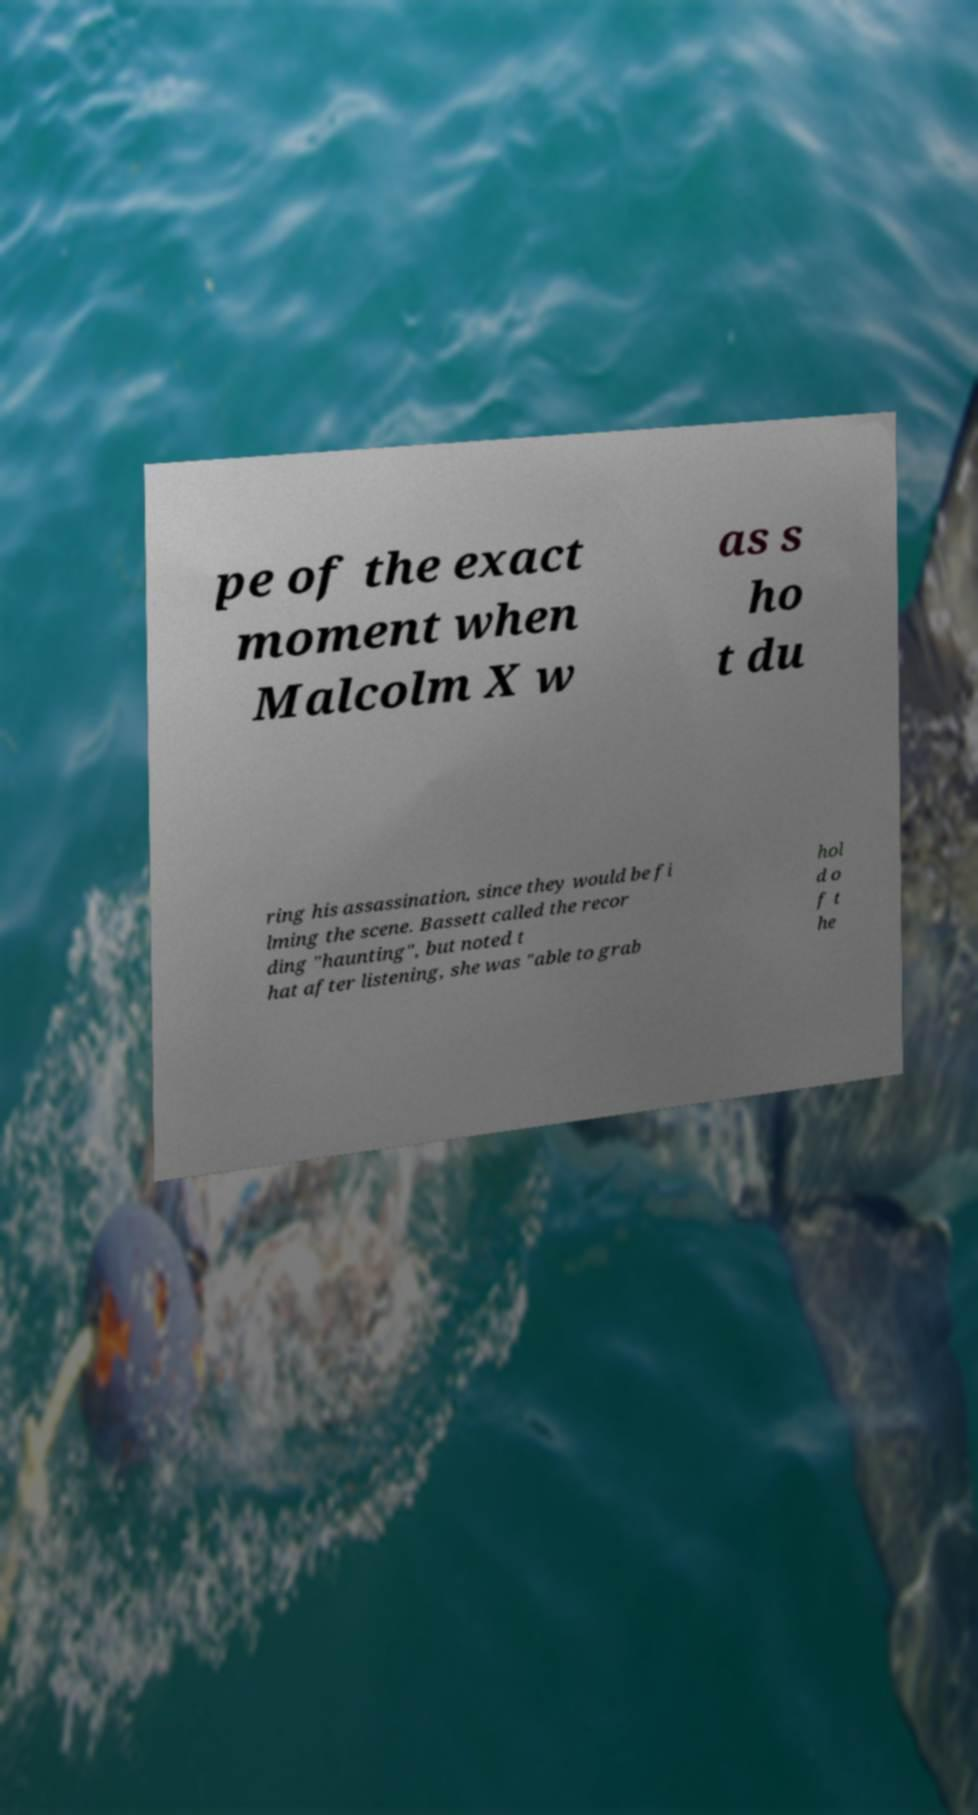Please identify and transcribe the text found in this image. pe of the exact moment when Malcolm X w as s ho t du ring his assassination, since they would be fi lming the scene. Bassett called the recor ding "haunting", but noted t hat after listening, she was "able to grab hol d o f t he 